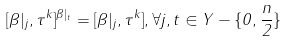Convert formula to latex. <formula><loc_0><loc_0><loc_500><loc_500>[ \beta | _ { j } , \tau ^ { k } ] ^ { \beta | _ { t } } = [ \beta | _ { j } , \tau ^ { k } ] , \forall j , t \in Y - \{ 0 , \frac { n } { 2 } \}</formula> 